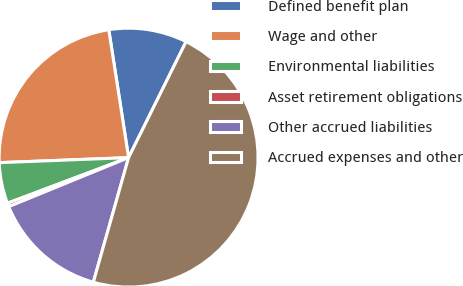Convert chart. <chart><loc_0><loc_0><loc_500><loc_500><pie_chart><fcel>Defined benefit plan<fcel>Wage and other<fcel>Environmental liabilities<fcel>Asset retirement obligations<fcel>Other accrued liabilities<fcel>Accrued expenses and other<nl><fcel>9.77%<fcel>23.17%<fcel>5.11%<fcel>0.45%<fcel>14.43%<fcel>47.06%<nl></chart> 